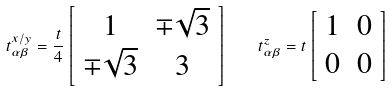<formula> <loc_0><loc_0><loc_500><loc_500>t _ { \alpha \beta } ^ { x / y } = \frac { t } { 4 } \left [ \begin{array} { c c } 1 & \mp \sqrt { 3 } \\ \mp \sqrt { 3 } & 3 \end{array} \right ] \quad t _ { \alpha \beta } ^ { z } = t \left [ \begin{array} { c c } 1 & 0 \\ 0 & 0 \end{array} \right ]</formula> 